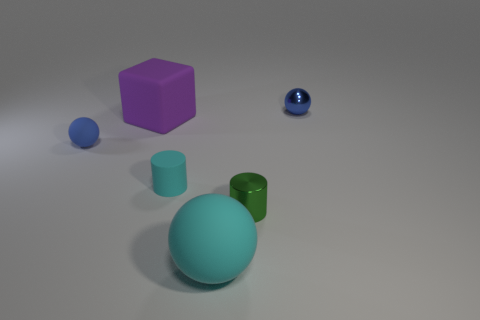Which object stands out the most to you and why? The large turquoise sphere stands out the most due to its size, central placement, and the contrast of its matte surface against the other objects' various textures and colors.  Can you describe the texture of the surfaces? Certainly, the large sphere, cube, and cylinder have a matte finish, which diffuses the light and gives a soft appearance. In contrast, the small shiny sphere has a reflective surface that mirrors the environment, making it glisten. 